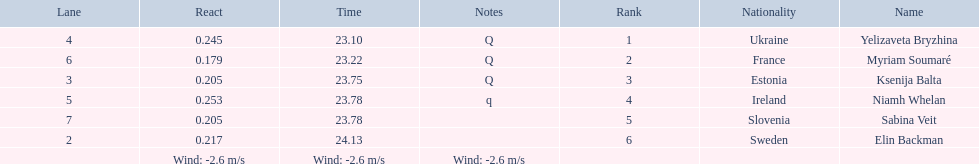What place did elin backman finish the race in? 6. How long did it take him to finish? 24.13. 